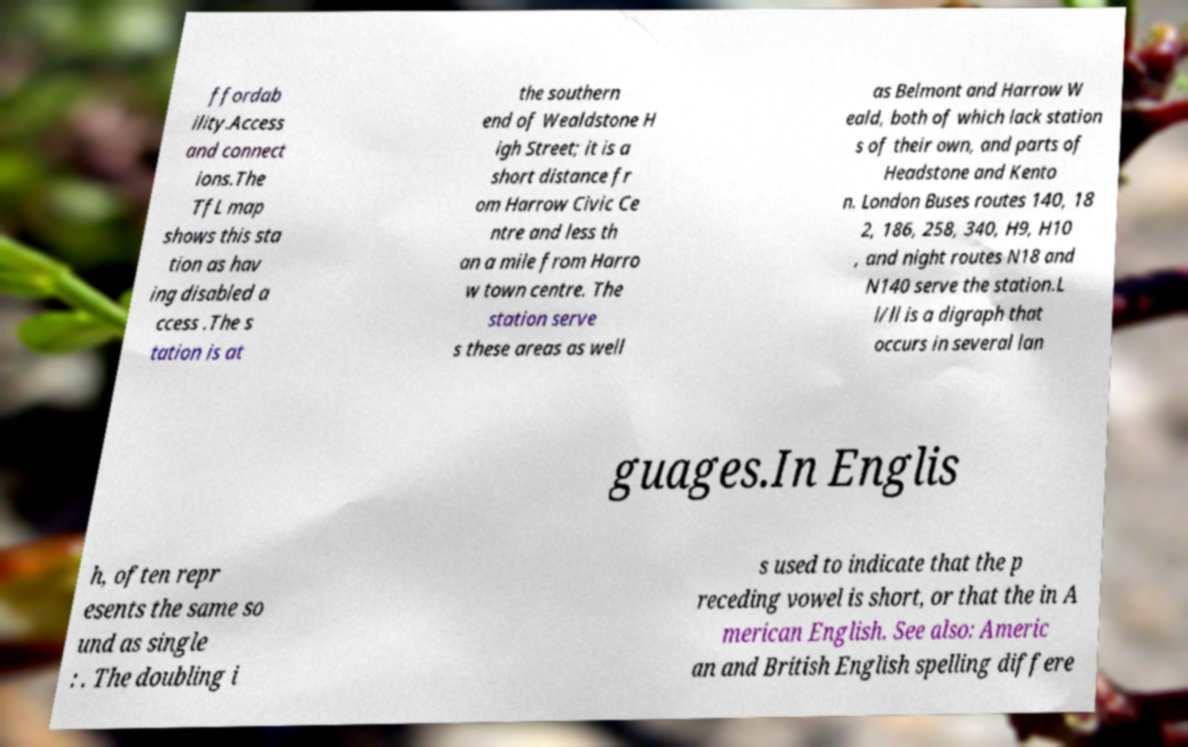Please identify and transcribe the text found in this image. ffordab ility.Access and connect ions.The TfL map shows this sta tion as hav ing disabled a ccess .The s tation is at the southern end of Wealdstone H igh Street; it is a short distance fr om Harrow Civic Ce ntre and less th an a mile from Harro w town centre. The station serve s these areas as well as Belmont and Harrow W eald, both of which lack station s of their own, and parts of Headstone and Kento n. London Buses routes 140, 18 2, 186, 258, 340, H9, H10 , and night routes N18 and N140 serve the station.L l/ll is a digraph that occurs in several lan guages.In Englis h, often repr esents the same so und as single : . The doubling i s used to indicate that the p receding vowel is short, or that the in A merican English. See also: Americ an and British English spelling differe 